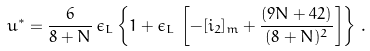<formula> <loc_0><loc_0><loc_500><loc_500>u ^ { \ast } = \frac { 6 } { 8 + N } \, \epsilon _ { L } \left \{ 1 + \epsilon _ { L } \, \left [ - [ i _ { 2 } ] _ { m } + \frac { ( 9 N + 4 2 ) } { ( 8 + N ) ^ { 2 } } \right ] \right \} \, .</formula> 